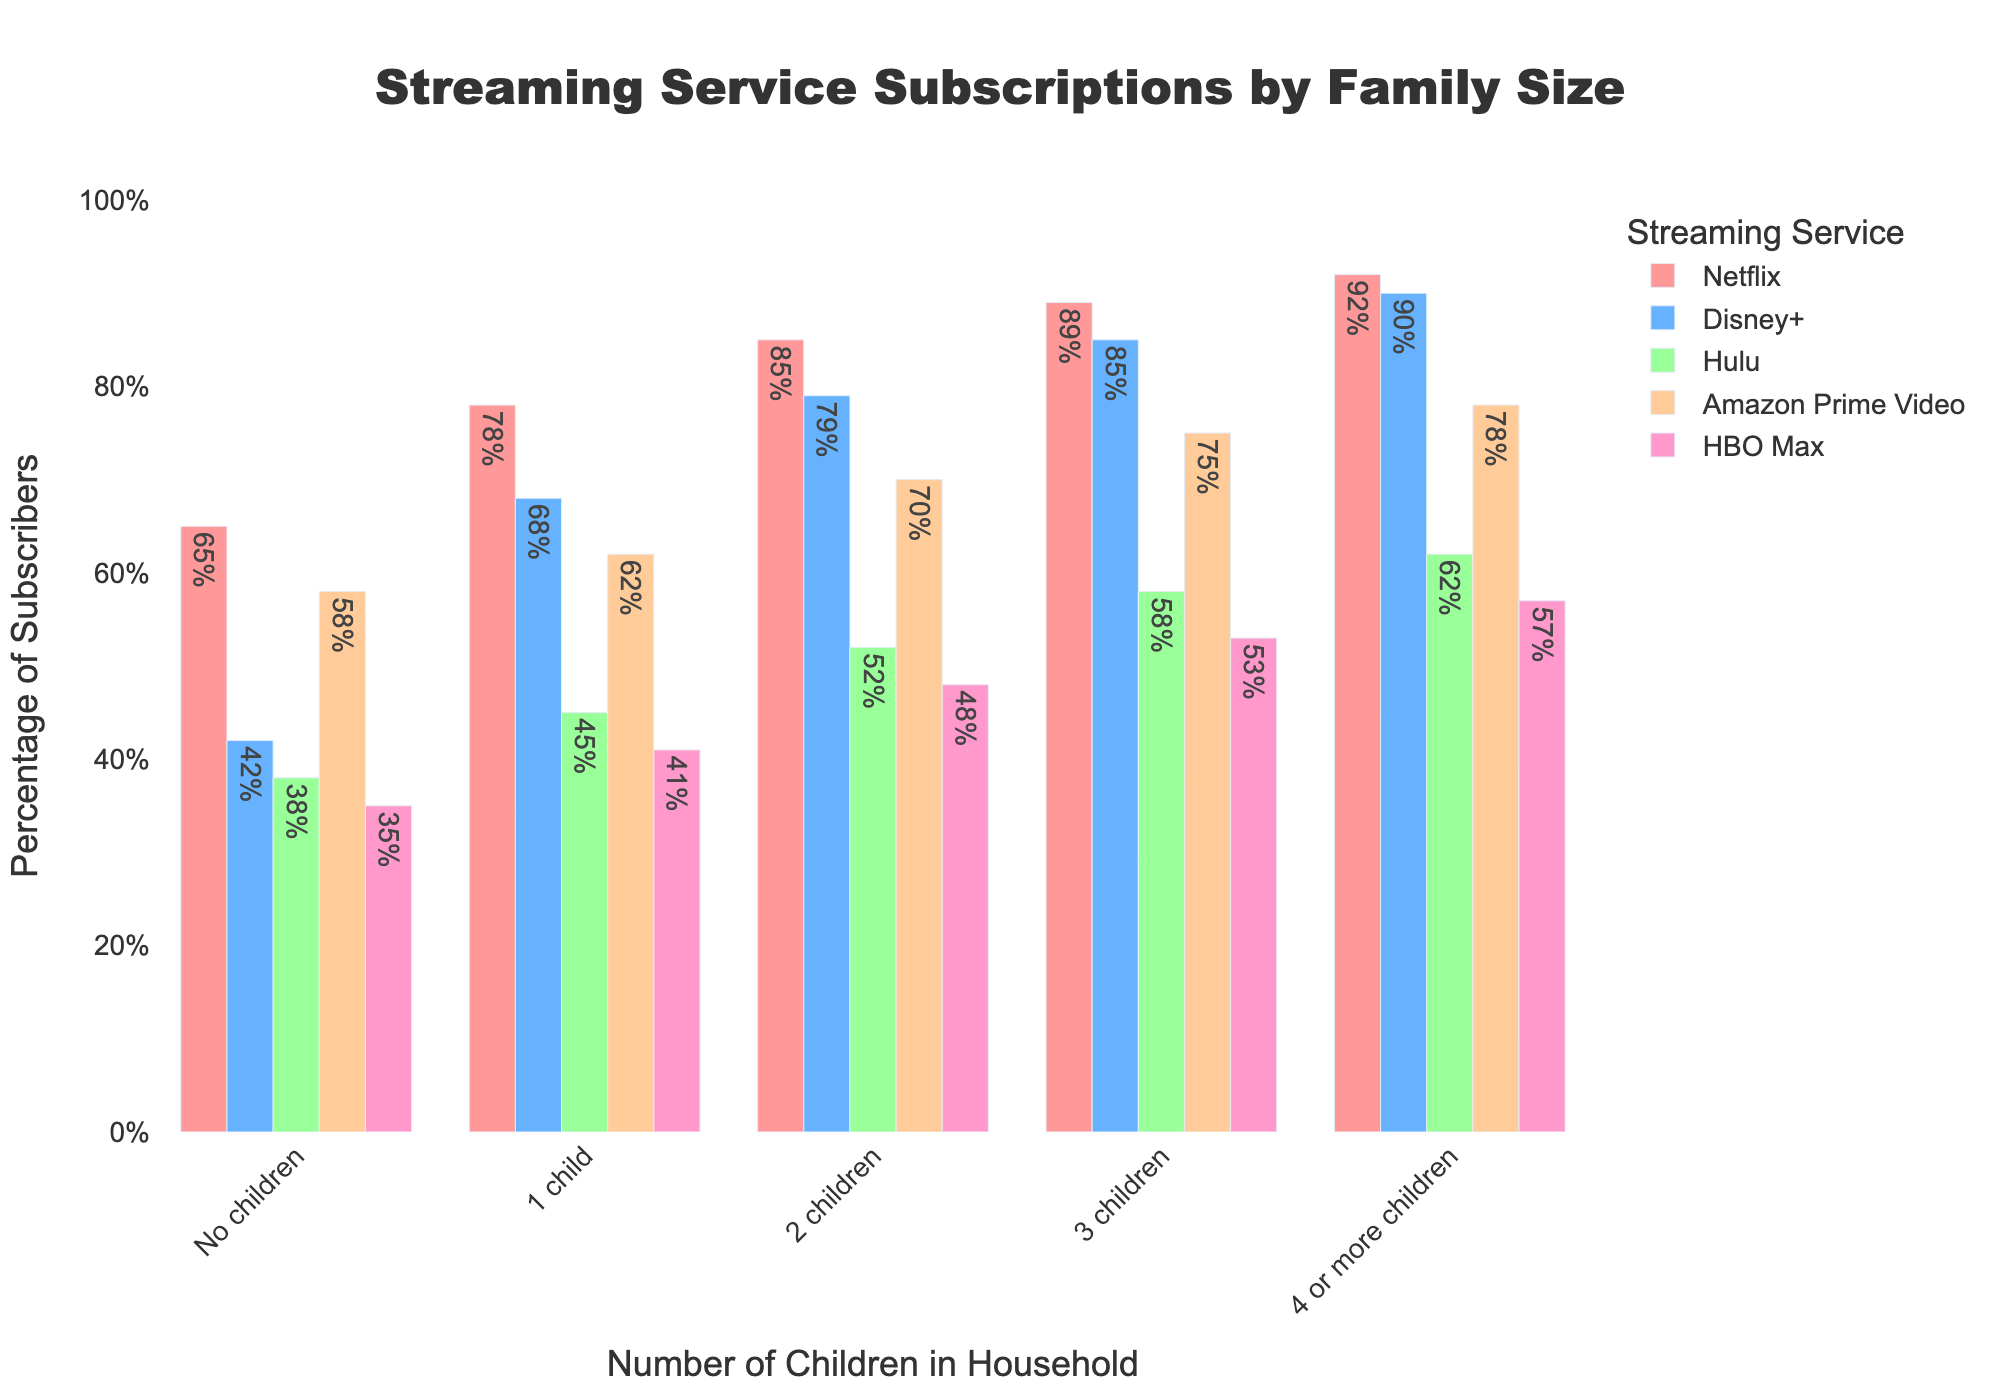Which streaming service has the highest subscription percentage among households with 3 children? To find the answer, look at the bar heights for households with 3 children and identify the tallest bar. The tallest bar corresponds to Netflix.
Answer: Netflix How much higher is the subscription percentage of Disney+ in households with 2 children compared to those with 1 child? Look at the Disney+ subscription percentages for households with 2 children (79%) and 1 child (68%). Subtract the percentage for 1 child from the percentage for 2 children: 79% - 68% = 11%.
Answer: 11% What is the difference in HBO Max subscription rates between households with no children and households with 4 or more children? Look at the HBO Max subscription percentages for no children (35%) and 4 or more children (57%). Subtract the no children percentage from the 4 or more children percentage: 57% - 35% = 22%.
Answer: 22% Which streaming service shows the least increase in subscription percentage from households with 1 child to households with 2 children? Calculate the increase in percentage for each streaming service from 1 child to 2 children. The differences are: Netflix (85% - 78% = 7%), Disney+ (79% - 68% = 11%), Hulu (52% - 45% = 7%), Amazon Prime Video (70% - 62% = 8%), HBO Max (48% - 41% = 7%). The smallest differences are for Netflix, Hulu, and HBO Max, all with an increase of 7%.
Answer: Netflix, Hulu, and HBO Max What is the average subscription rate for Hulu across all household sizes? Calculate the average by summing the Hulu percentages for each household group and dividing by the number of groups: (38% + 45% + 52% + 58% + 62%) / 5 = 51%.
Answer: 51% Which two streaming services have nearly equal subscription percentages in households without children? Look at the bar heights in the "No children" category. Disney+ has 42%, and Hulu has 38%, the closest to each other compared to other streaming services.
Answer: Disney+ and Hulu How does the subscription rate of Amazon Prime Video compare between households with no children and those with 3 children? Compare the heights of the Amazon Prime Video bars for no children (58%) and 3 children (75%). The rate for 3 children is higher.
Answer: Higher for 3 children On average, which streaming service has the highest subscription rate across all household sizes? Calculate the average for each streaming service: Netflix (82%), Disney+ (72.8%), Hulu (51%), Amazon Prime Video (68.6%), HBO Max (46.8%). Compare the averages. Netflix has the highest.
Answer: Netflix 